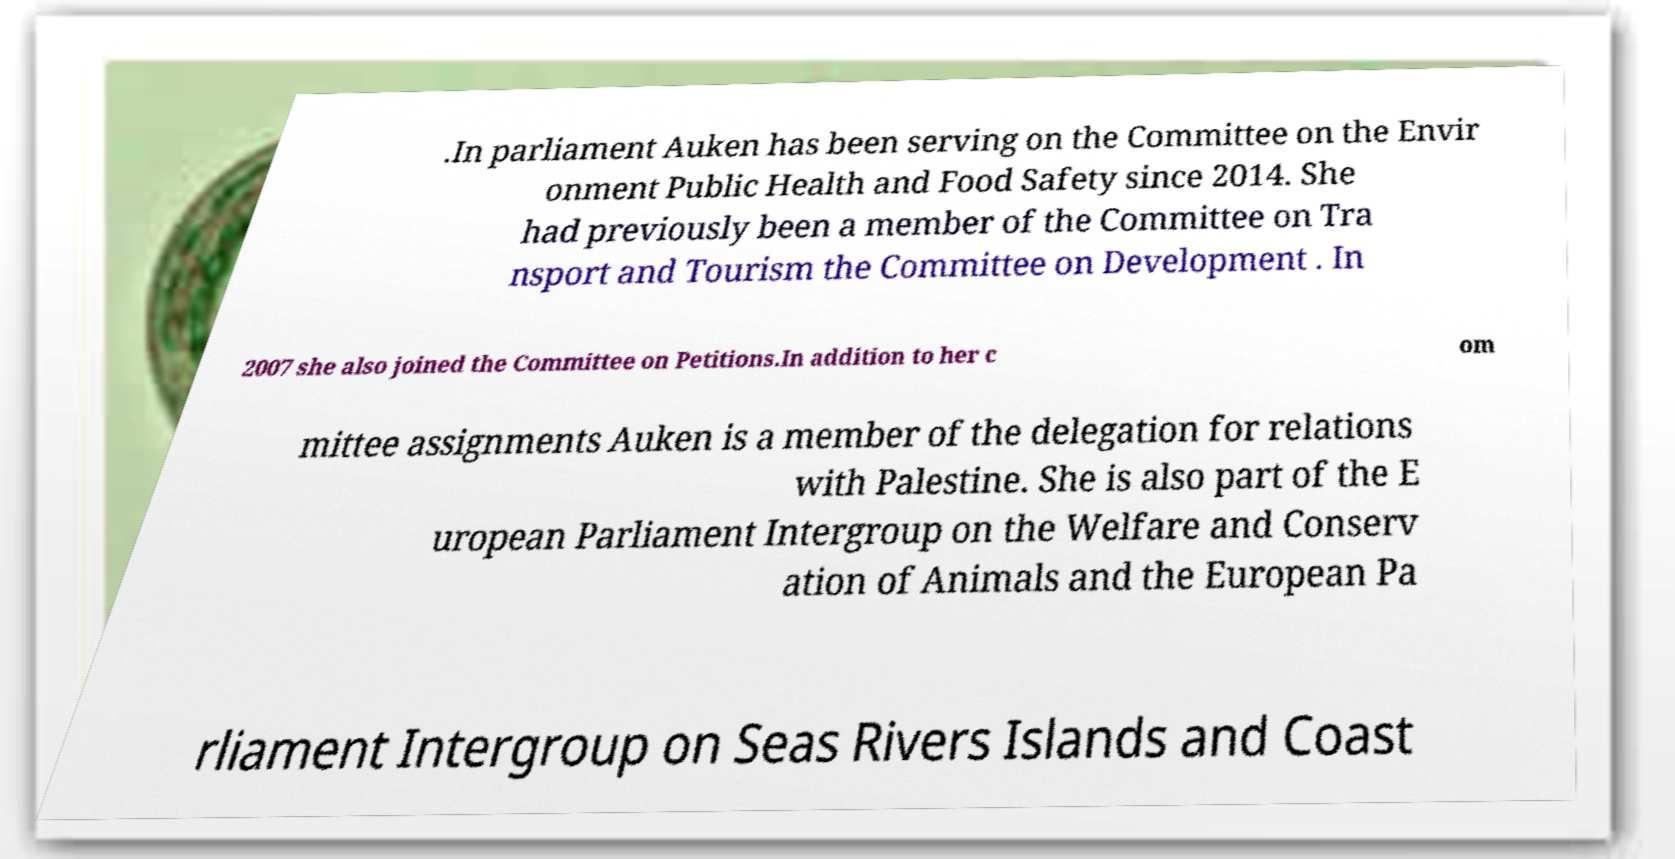Please read and relay the text visible in this image. What does it say? .In parliament Auken has been serving on the Committee on the Envir onment Public Health and Food Safety since 2014. She had previously been a member of the Committee on Tra nsport and Tourism the Committee on Development . In 2007 she also joined the Committee on Petitions.In addition to her c om mittee assignments Auken is a member of the delegation for relations with Palestine. She is also part of the E uropean Parliament Intergroup on the Welfare and Conserv ation of Animals and the European Pa rliament Intergroup on Seas Rivers Islands and Coast 